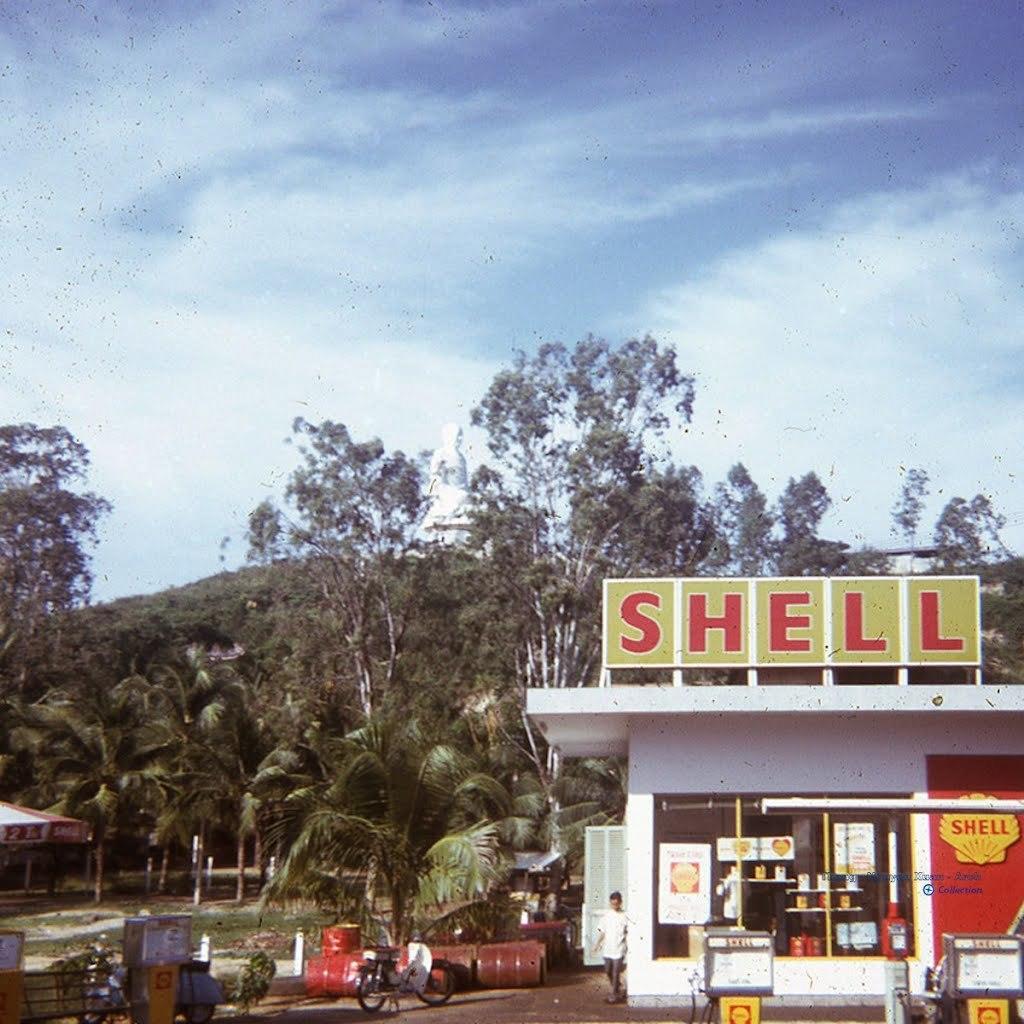Describe this image in one or two sentences. In this picture we can see a store here, in the background there are some trees, we can see a bicycle here, there is a person standing here, there is the sky at the top of the picture, we can see a board here, at the bottom there is some grass. 